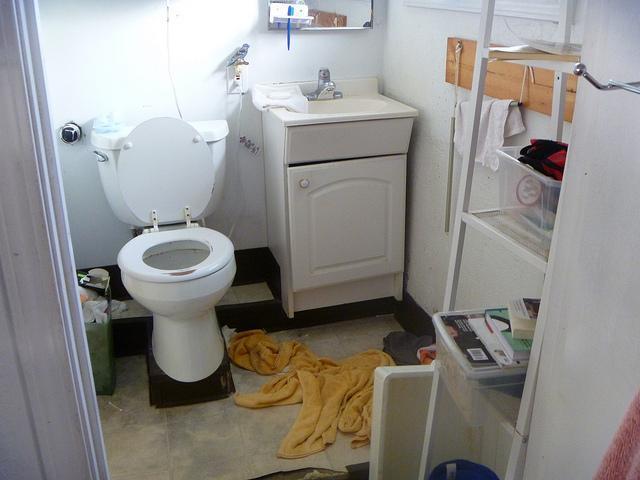How many people are in front of the tables?
Give a very brief answer. 0. 